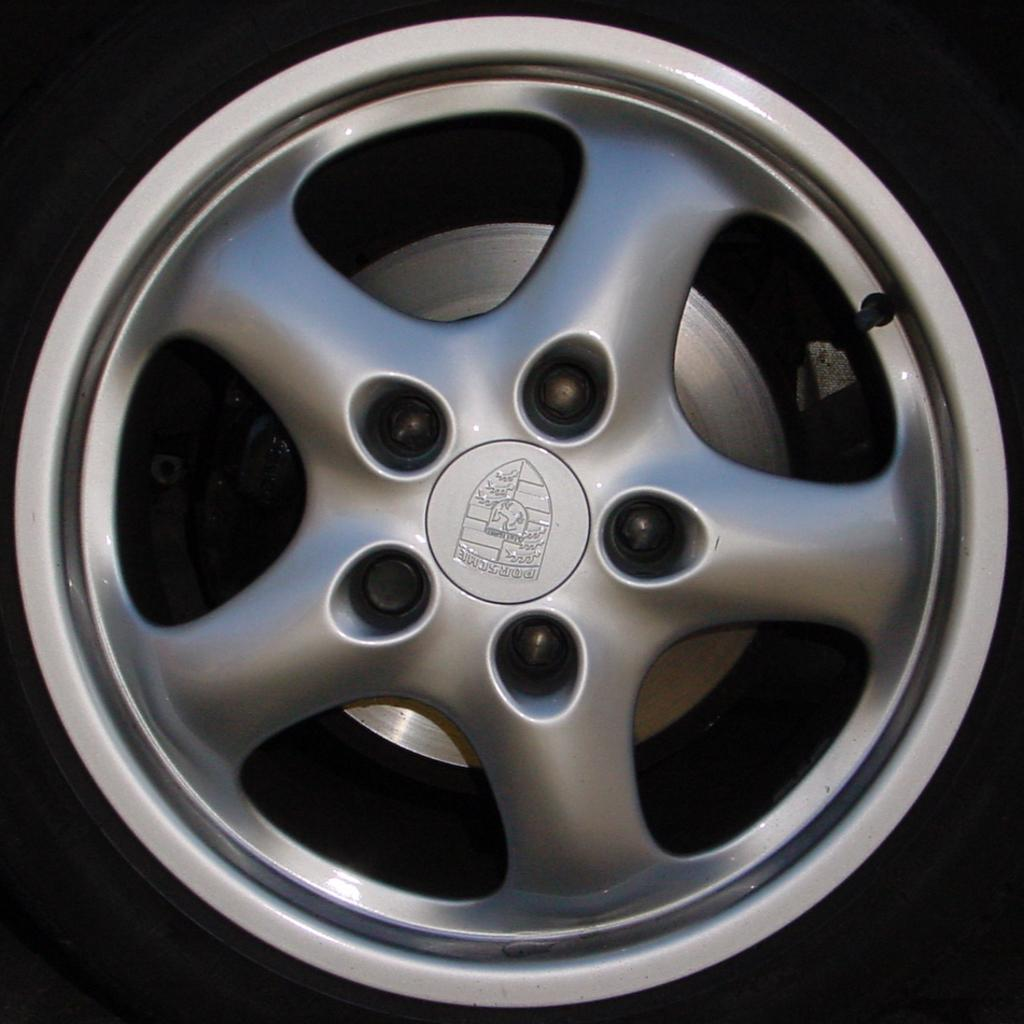What part of a vehicle can be seen in the image? The rim of a vehicle is visible in the image. What color is the background of the image? The background of the image is black. What type of shirt is your uncle wearing in the image? There is no uncle or shirt present in the image; it only features the rim of a vehicle and a black background. 